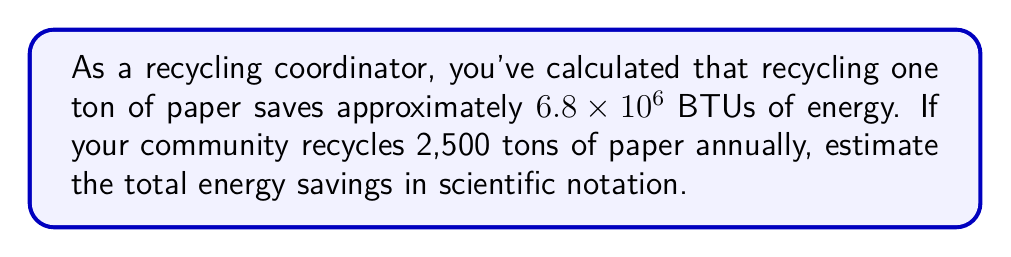Show me your answer to this math problem. To solve this problem, we'll follow these steps:

1) We know that recycling one ton of paper saves $6.8 \times 10^6$ BTUs.
2) The community recycles 2,500 tons annually.
3) We need to multiply these values:

   $$(6.8 \times 10^6) \times 2500$$

4) Let's separate this into the coefficient and exponent parts:

   $$(6.8 \times 2500) \times 10^6$$

5) Calculate $6.8 \times 2500$:

   $$17,000 \times 10^6$$

6) In scientific notation, we want the coefficient to be between 1 and 10. So, we'll move the decimal point 4 places to the left and increase the exponent by 4:

   $$1.7 \times 10^{10}$$

Thus, the estimated annual energy savings from recycling paper in your community is $1.7 \times 10^{10}$ BTUs.
Answer: $1.7 \times 10^{10}$ BTUs 